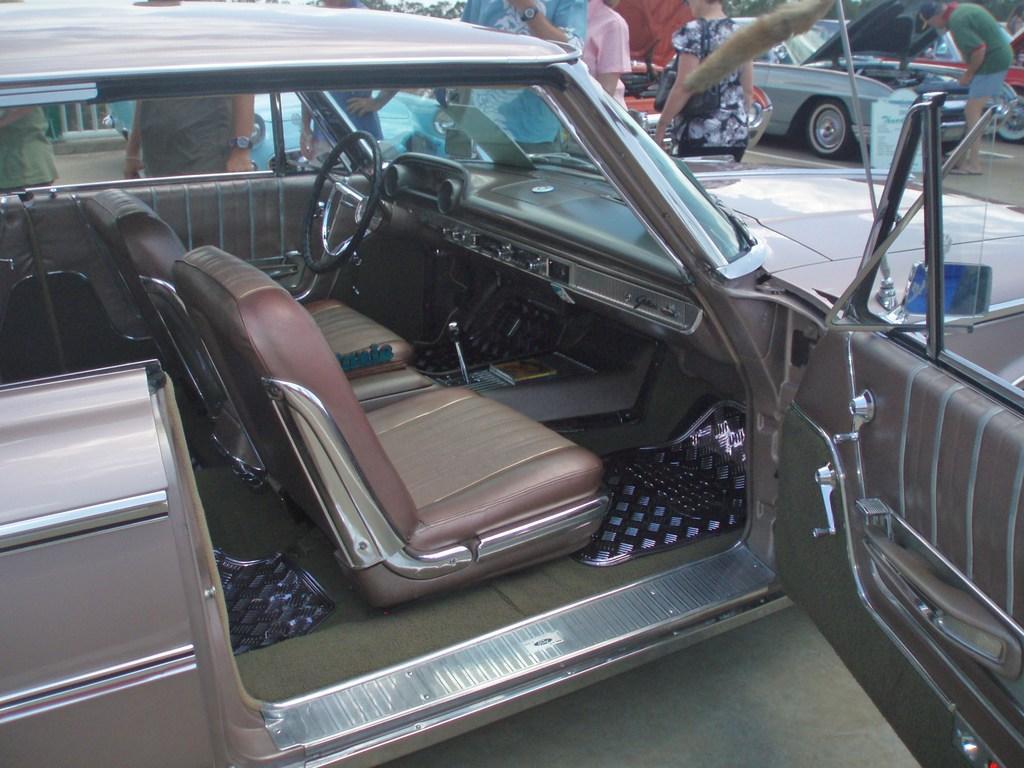Please provide a concise description of this image. In this image I can see the car and I can see the seats of the car, the steering, the dash board and the gear rod of the car. I can see the door and the windshield of the car. In the background I can see few persons standing, few vehicles and few trees. 